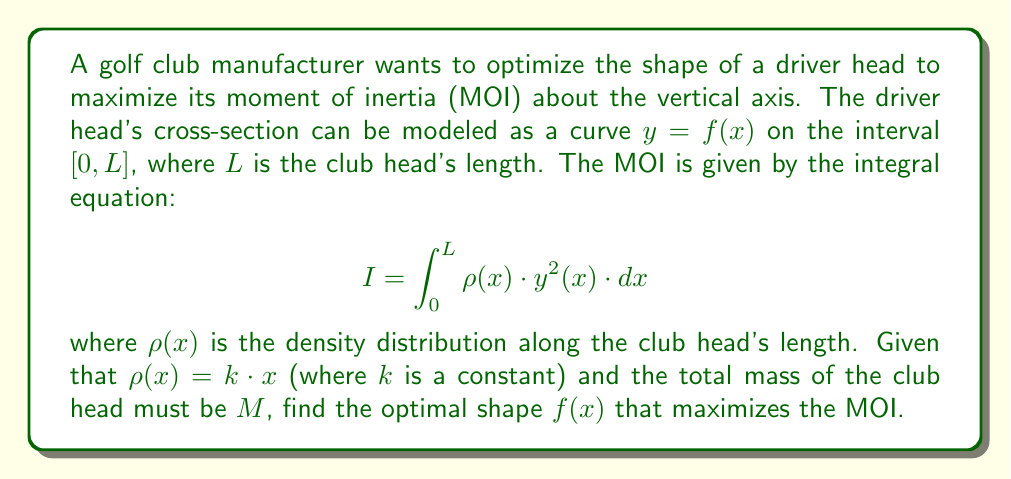Could you help me with this problem? To solve this optimization problem, we'll use the calculus of variations. The steps are as follows:

1) First, we need to consider the mass constraint:

   $$M = \int_0^L \rho(x) \cdot y(x) \cdot dx = k \int_0^L x \cdot y(x) \cdot dx$$

2) We can form a functional $J$ that includes both the MOI and the mass constraint:

   $$J[y] = \int_0^L kx \cdot y^2(x) \cdot dx - \lambda \left(\int_0^L kx \cdot y(x) \cdot dx - M\right)$$

   where $\lambda$ is a Lagrange multiplier.

3) The Euler-Lagrange equation for this functional is:

   $$\frac{\partial}{\partial y}\left(kx \cdot y^2 - \lambda kx \cdot y\right) - \frac{d}{dx}\frac{\partial}{\partial y'}\left(kx \cdot y^2 - \lambda kx \cdot y\right) = 0$$

4) Simplifying:

   $$2kx \cdot y - \lambda kx = 0$$

5) Solving for $y$:

   $$y(x) = \frac{\lambda}{2}$$

6) This shows that the optimal shape is a constant function, independent of $x$.

7) To find $\lambda$, we use the mass constraint:

   $$M = k \int_0^L x \cdot \frac{\lambda}{2} \cdot dx = \frac{k\lambda L^2}{4}$$

8) Solving for $\lambda$:

   $$\lambda = \frac{4M}{kL^2}$$

9) Therefore, the optimal shape function is:

   $$f(x) = y(x) = \frac{2M}{kL^2}$$

This constant function represents a rectangular cross-section, which provides the maximum MOI for the given constraints.
Answer: $f(x) = \frac{2M}{kL^2}$ 